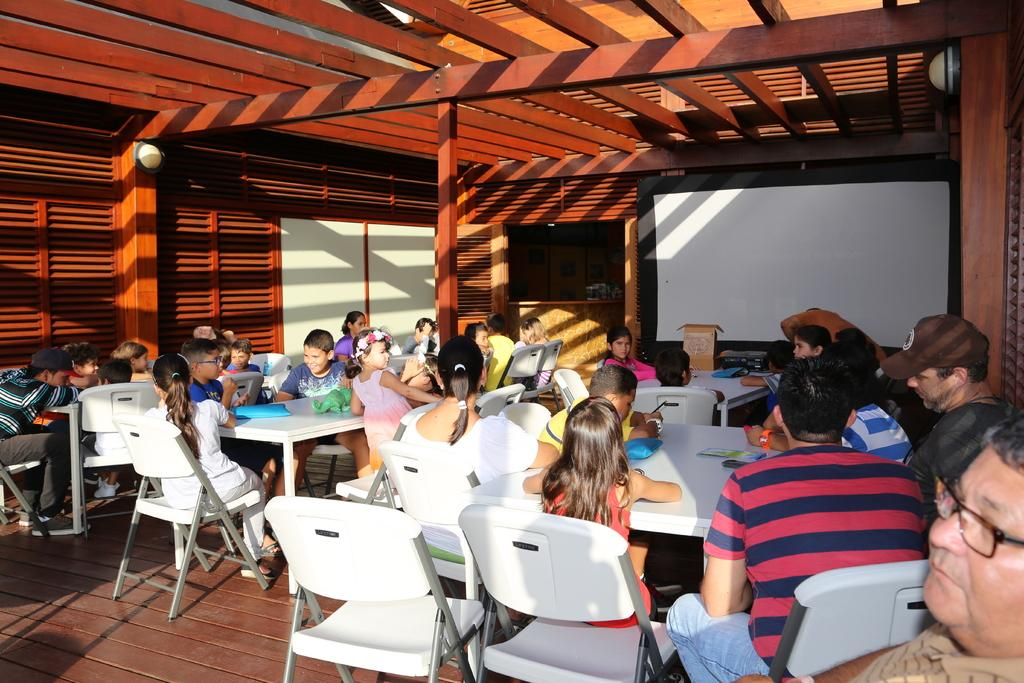What are the people in the image doing? The people in the image are sitting on chairs. How are the chairs arranged in the image? The chairs are arranged around tables. tables. What can be seen on the wall or surface behind the people? There is a white screen visible in the image. What type of pie is being served on the tables in the image? There is no pie visible in the image; only chairs, tables, and a white screen are present. 